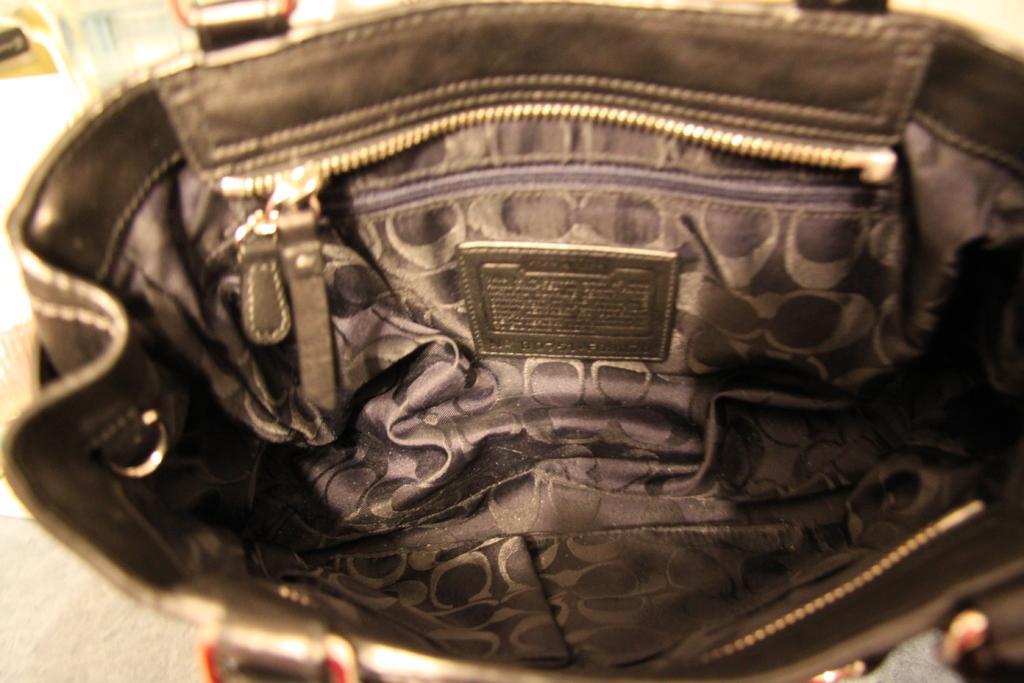Can you describe this image briefly? This is the inside view of a handbag. 